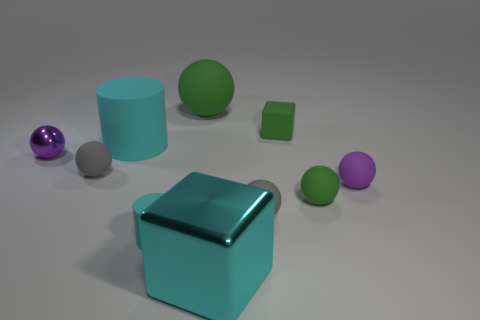Subtract 2 blocks. How many blocks are left? 0 Subtract all red cubes. How many gray cylinders are left? 0 Subtract all small cyan spheres. Subtract all large cyan metal things. How many objects are left? 9 Add 7 gray matte balls. How many gray matte balls are left? 9 Add 5 tiny cyan matte objects. How many tiny cyan matte objects exist? 6 Subtract all green cubes. How many cubes are left? 1 Subtract all big green spheres. How many spheres are left? 5 Subtract 1 purple balls. How many objects are left? 9 Subtract all cylinders. How many objects are left? 8 Subtract all yellow balls. Subtract all green cylinders. How many balls are left? 6 